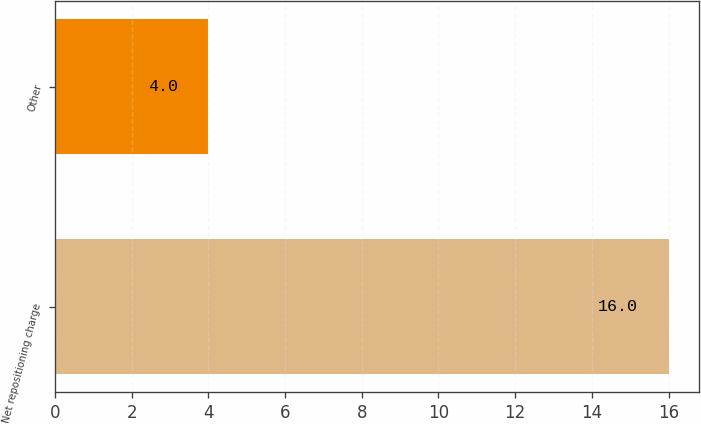Convert chart to OTSL. <chart><loc_0><loc_0><loc_500><loc_500><bar_chart><fcel>Net repositioning charge<fcel>Other<nl><fcel>16<fcel>4<nl></chart> 